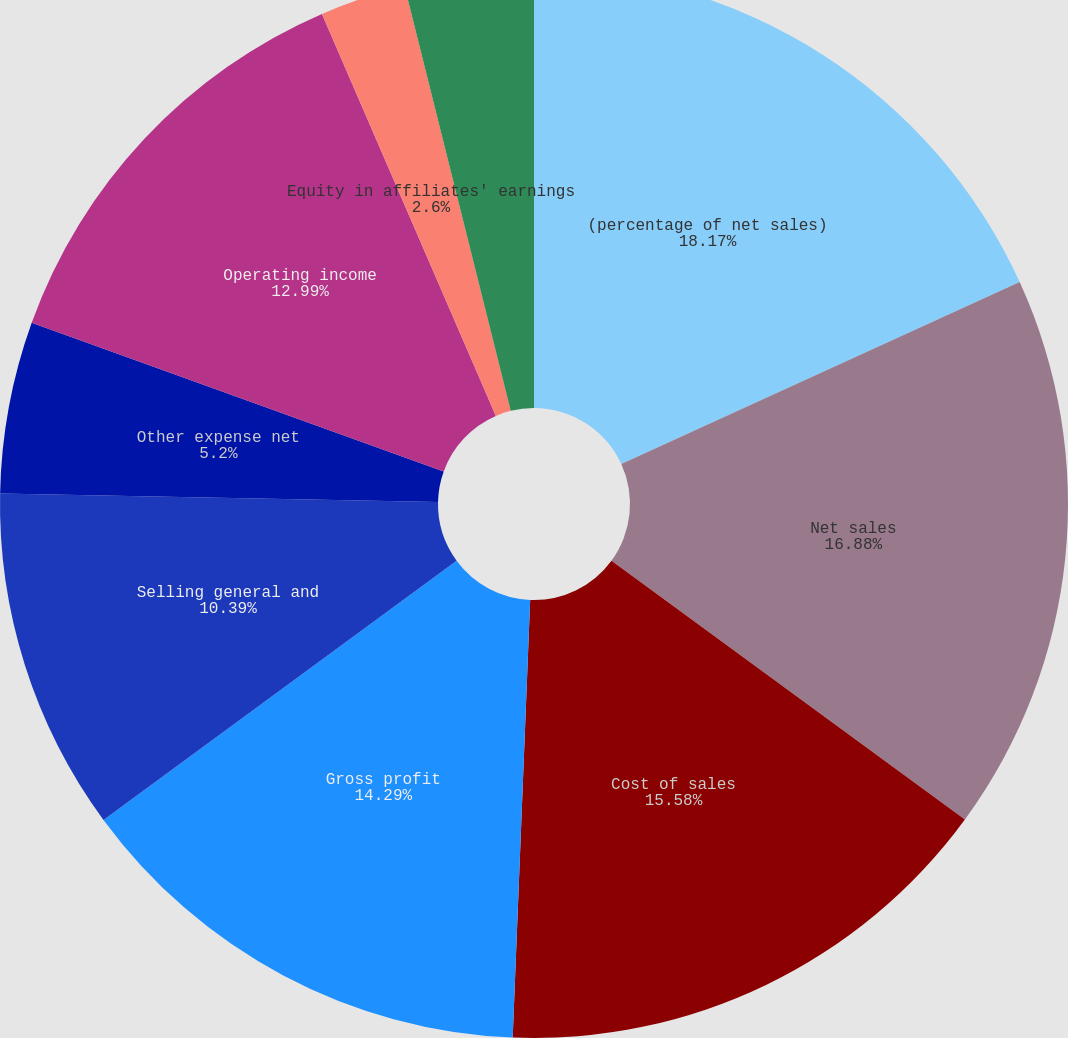Convert chart to OTSL. <chart><loc_0><loc_0><loc_500><loc_500><pie_chart><fcel>(percentage of net sales)<fcel>Net sales<fcel>Cost of sales<fcel>Gross profit<fcel>Selling general and<fcel>Other expense net<fcel>Operating income<fcel>Equity in affiliates' earnings<fcel>Interest income<fcel>Interest expense and finance<nl><fcel>18.18%<fcel>16.88%<fcel>15.58%<fcel>14.29%<fcel>10.39%<fcel>5.2%<fcel>12.99%<fcel>2.6%<fcel>0.0%<fcel>3.9%<nl></chart> 